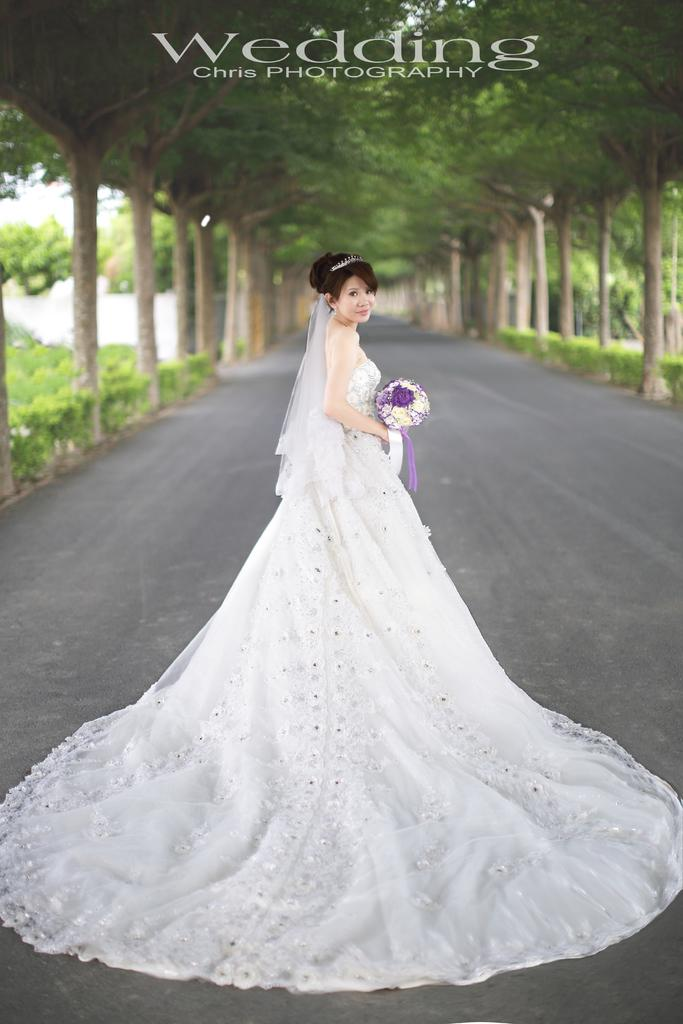Who is present in the image? There is a woman in the image. What is the woman doing in the image? The woman is standing on the road and holding a flower bouquet. What can be seen in the background of the image? There are trees in the background of the image. What time of day is it in the image, and what is the woman teaching? The time of day is not mentioned in the image, and the woman is not teaching anything. The image only shows a woman standing on the road holding a flower bouquet, with trees in the background. 